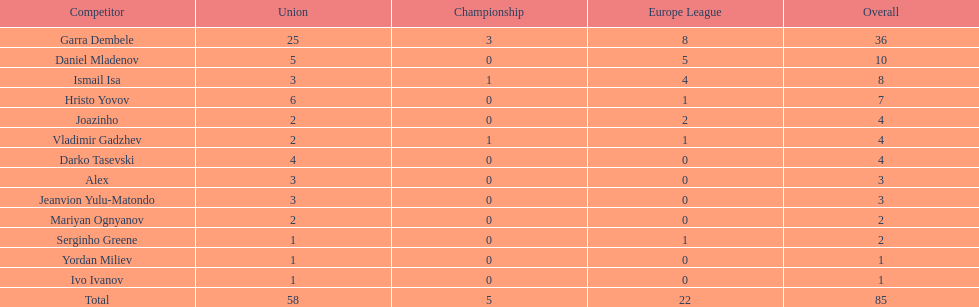Could you help me parse every detail presented in this table? {'header': ['Competitor', 'Union', 'Championship', 'Europe League', 'Overall'], 'rows': [['Garra Dembele', '25', '3', '8', '36'], ['Daniel Mladenov', '5', '0', '5', '10'], ['Ismail Isa', '3', '1', '4', '8'], ['Hristo Yovov', '6', '0', '1', '7'], ['Joazinho', '2', '0', '2', '4'], ['Vladimir Gadzhev', '2', '1', '1', '4'], ['Darko Tasevski', '4', '0', '0', '4'], ['Alex', '3', '0', '0', '3'], ['Jeanvion Yulu-Matondo', '3', '0', '0', '3'], ['Mariyan Ognyanov', '2', '0', '0', '2'], ['Serginho Greene', '1', '0', '1', '2'], ['Yordan Miliev', '1', '0', '0', '1'], ['Ivo Ivanov', '1', '0', '0', '1'], ['Total', '58', '5', '22', '85']]} What is the difference between vladimir gadzhev and yordan miliev's scores? 3. 